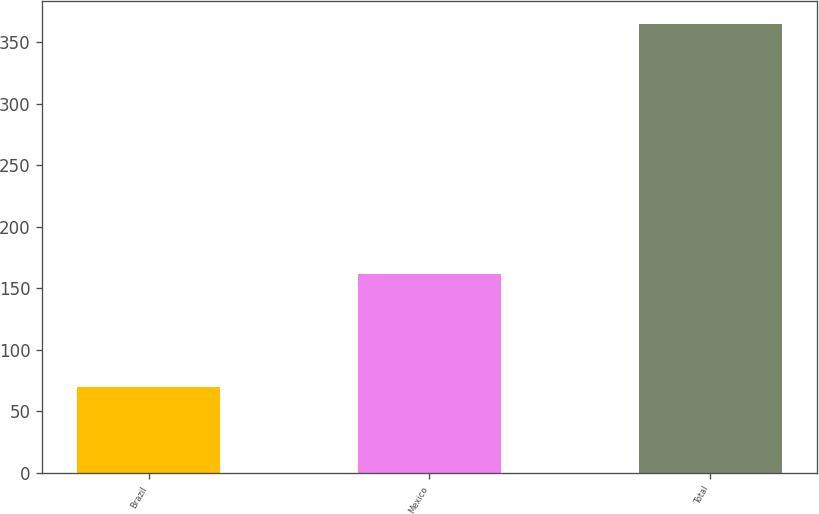Convert chart to OTSL. <chart><loc_0><loc_0><loc_500><loc_500><bar_chart><fcel>Brazil<fcel>Mexico<fcel>Total<nl><fcel>70<fcel>162<fcel>365<nl></chart> 